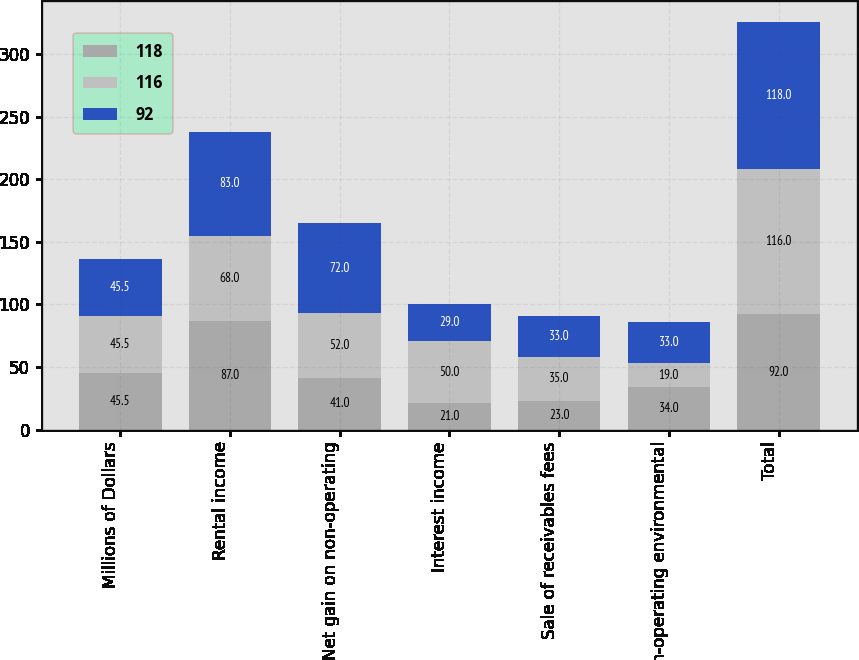<chart> <loc_0><loc_0><loc_500><loc_500><stacked_bar_chart><ecel><fcel>Millions of Dollars<fcel>Rental income<fcel>Net gain on non-operating<fcel>Interest income<fcel>Sale of receivables fees<fcel>Non-operating environmental<fcel>Total<nl><fcel>118<fcel>45.5<fcel>87<fcel>41<fcel>21<fcel>23<fcel>34<fcel>92<nl><fcel>116<fcel>45.5<fcel>68<fcel>52<fcel>50<fcel>35<fcel>19<fcel>116<nl><fcel>92<fcel>45.5<fcel>83<fcel>72<fcel>29<fcel>33<fcel>33<fcel>118<nl></chart> 